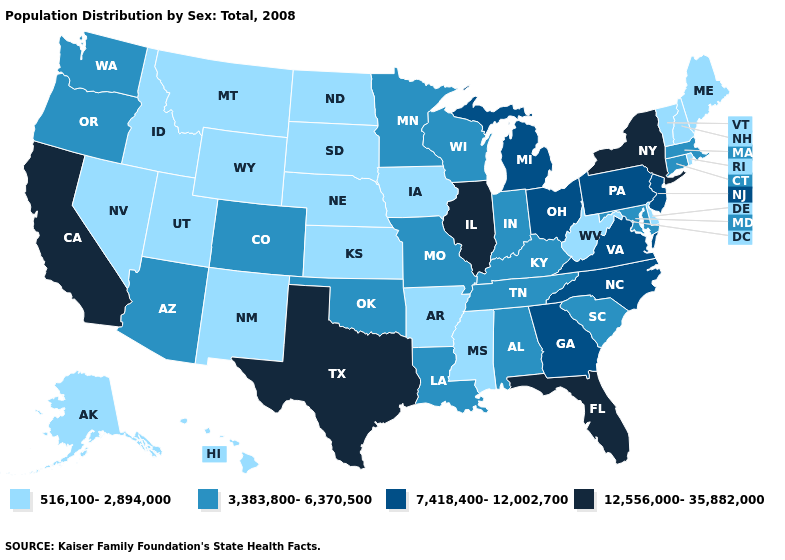Which states have the lowest value in the USA?
Short answer required. Alaska, Arkansas, Delaware, Hawaii, Idaho, Iowa, Kansas, Maine, Mississippi, Montana, Nebraska, Nevada, New Hampshire, New Mexico, North Dakota, Rhode Island, South Dakota, Utah, Vermont, West Virginia, Wyoming. What is the lowest value in states that border Minnesota?
Keep it brief. 516,100-2,894,000. What is the lowest value in the Northeast?
Concise answer only. 516,100-2,894,000. What is the lowest value in the West?
Concise answer only. 516,100-2,894,000. Does Maine have the highest value in the Northeast?
Be succinct. No. What is the highest value in the USA?
Write a very short answer. 12,556,000-35,882,000. Is the legend a continuous bar?
Quick response, please. No. Which states hav the highest value in the MidWest?
Keep it brief. Illinois. Among the states that border New Hampshire , which have the highest value?
Short answer required. Massachusetts. Name the states that have a value in the range 12,556,000-35,882,000?
Give a very brief answer. California, Florida, Illinois, New York, Texas. What is the value of South Carolina?
Be succinct. 3,383,800-6,370,500. Name the states that have a value in the range 3,383,800-6,370,500?
Answer briefly. Alabama, Arizona, Colorado, Connecticut, Indiana, Kentucky, Louisiana, Maryland, Massachusetts, Minnesota, Missouri, Oklahoma, Oregon, South Carolina, Tennessee, Washington, Wisconsin. What is the value of Vermont?
Quick response, please. 516,100-2,894,000. Name the states that have a value in the range 12,556,000-35,882,000?
Answer briefly. California, Florida, Illinois, New York, Texas. Among the states that border Wisconsin , does Illinois have the highest value?
Be succinct. Yes. 